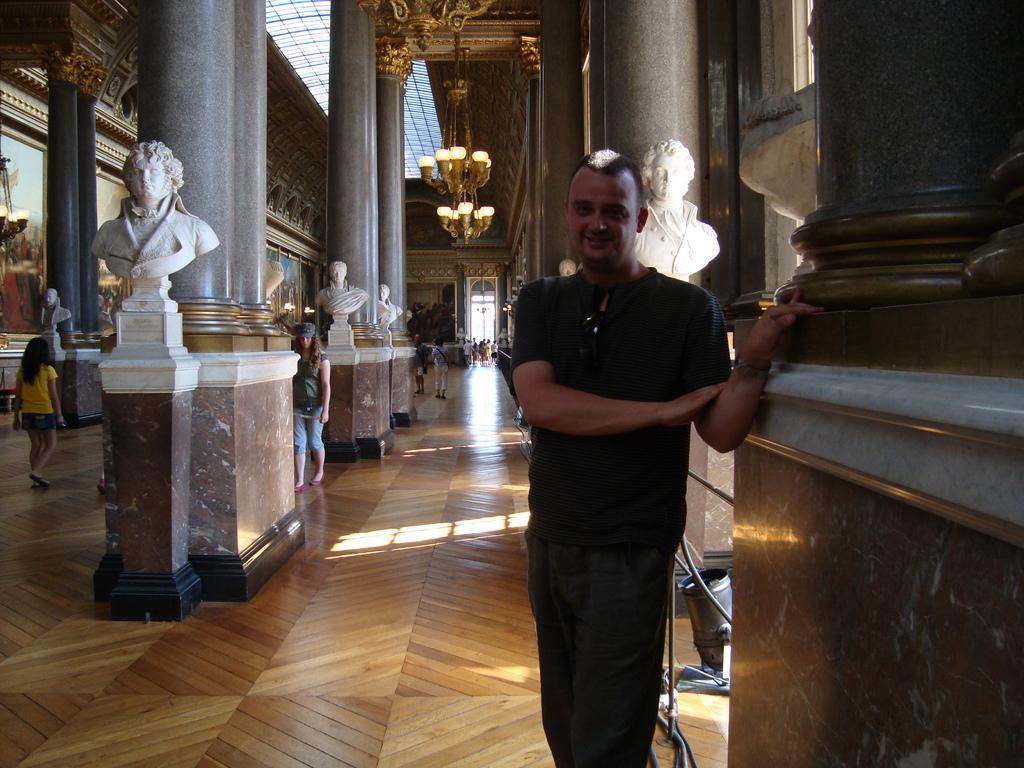Describe this image in one or two sentences. In this image I can see a person wearing black color dress is standing on the cream and brown colored floor. I can see few white colored statues, few persons standing, few pillars, few chandeliers, few photo frames, the entrance door and the ceiling of the building. 